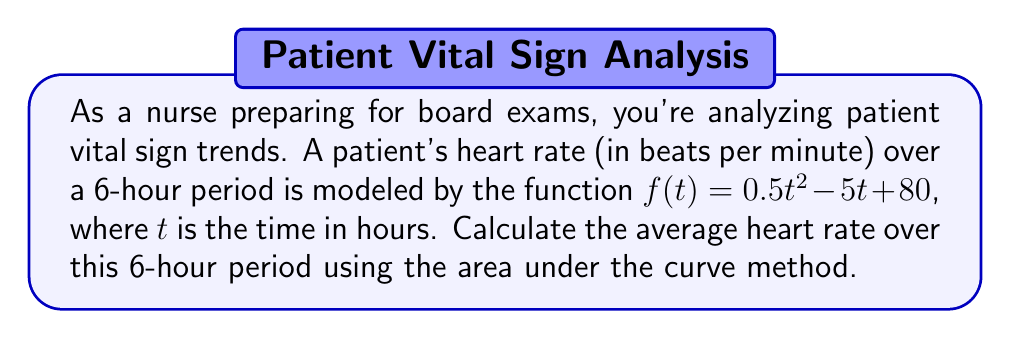What is the answer to this math problem? To find the average heart rate over the 6-hour period, we need to:

1. Calculate the area under the curve (total heartbeats)
2. Divide the area by the time period (6 hours)

Step 1: Calculate the area under the curve

The area under the curve is given by the definite integral of $f(t)$ from $t=0$ to $t=6$:

$$\int_0^6 (0.5t^2 - 5t + 80) dt$$

Let's integrate this function:

$$\left[\frac{0.5t^3}{3} - \frac{5t^2}{2} + 80t\right]_0^6$$

Now, evaluate at the limits:

$$\left(\frac{0.5(6^3)}{3} - \frac{5(6^2)}{2} + 80(6)\right) - \left(\frac{0.5(0^3)}{3} - \frac{5(0^2)}{2} + 80(0)\right)$$

$$= (36 - 90 + 480) - (0 - 0 + 0) = 426$$

Step 2: Calculate the average heart rate

Average heart rate = Total heartbeats / Time period
$$\frac{426}{6} = 71$$

Therefore, the average heart rate over the 6-hour period is 71 beats per minute.
Answer: 71 beats per minute 